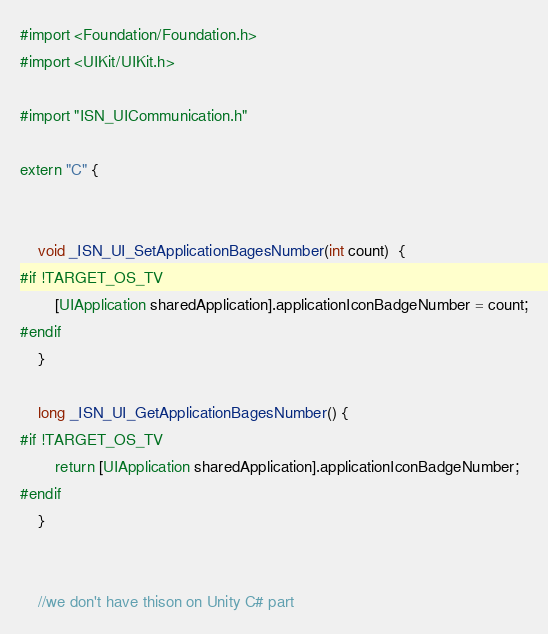Convert code to text. <code><loc_0><loc_0><loc_500><loc_500><_ObjectiveC_>#import <Foundation/Foundation.h>
#import <UIKit/UIKit.h>

#import "ISN_UICommunication.h"

extern "C" {
    
    
    void _ISN_UI_SetApplicationBagesNumber(int count)  {
#if !TARGET_OS_TV
        [UIApplication sharedApplication].applicationIconBadgeNumber = count;
#endif
    }
    
    long _ISN_UI_GetApplicationBagesNumber() {
#if !TARGET_OS_TV
        return [UIApplication sharedApplication].applicationIconBadgeNumber;
#endif
    }
    
    
    //we don't have thison on Unity C# part</code> 